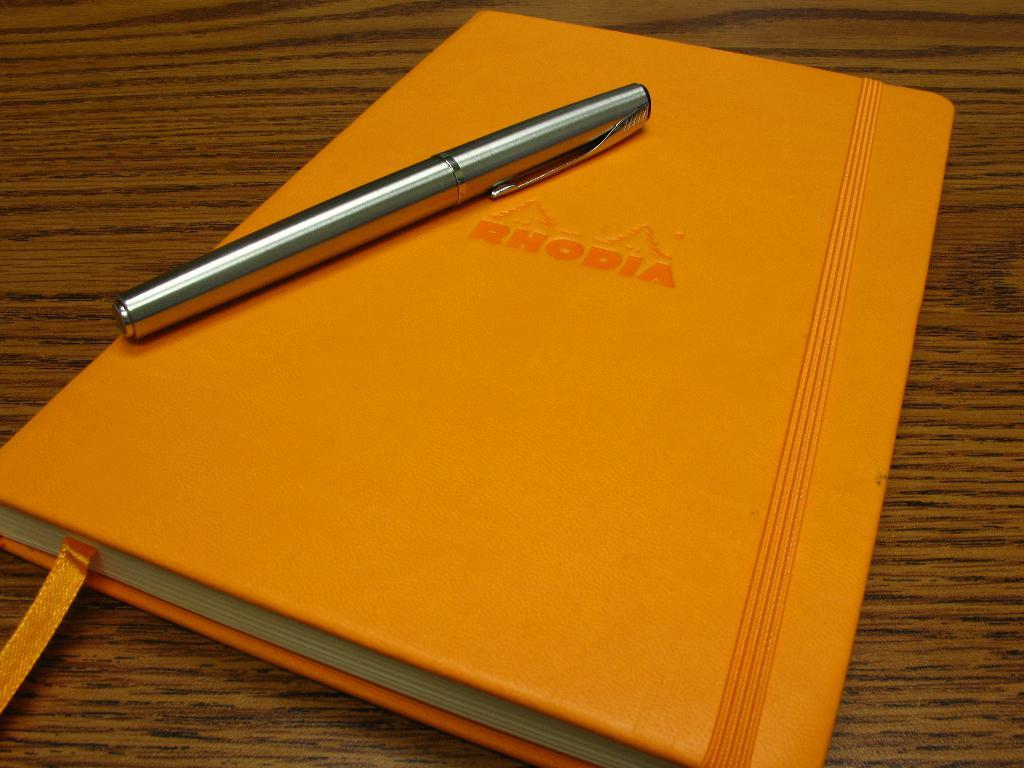What object can be seen in the image related to reading or writing? There is a book in the image, which is related to reading, and a pen, which is related to writing. Where are the book and pen located in the image? The book and pen are on a wooden platform. What type of bomb is depicted in the image? There is no bomb present in the image; it features a book and a pen on a wooden platform. Is there a ship visible in the image? There is no ship present in the image; it only shows a book, a pen, and a wooden platform. 